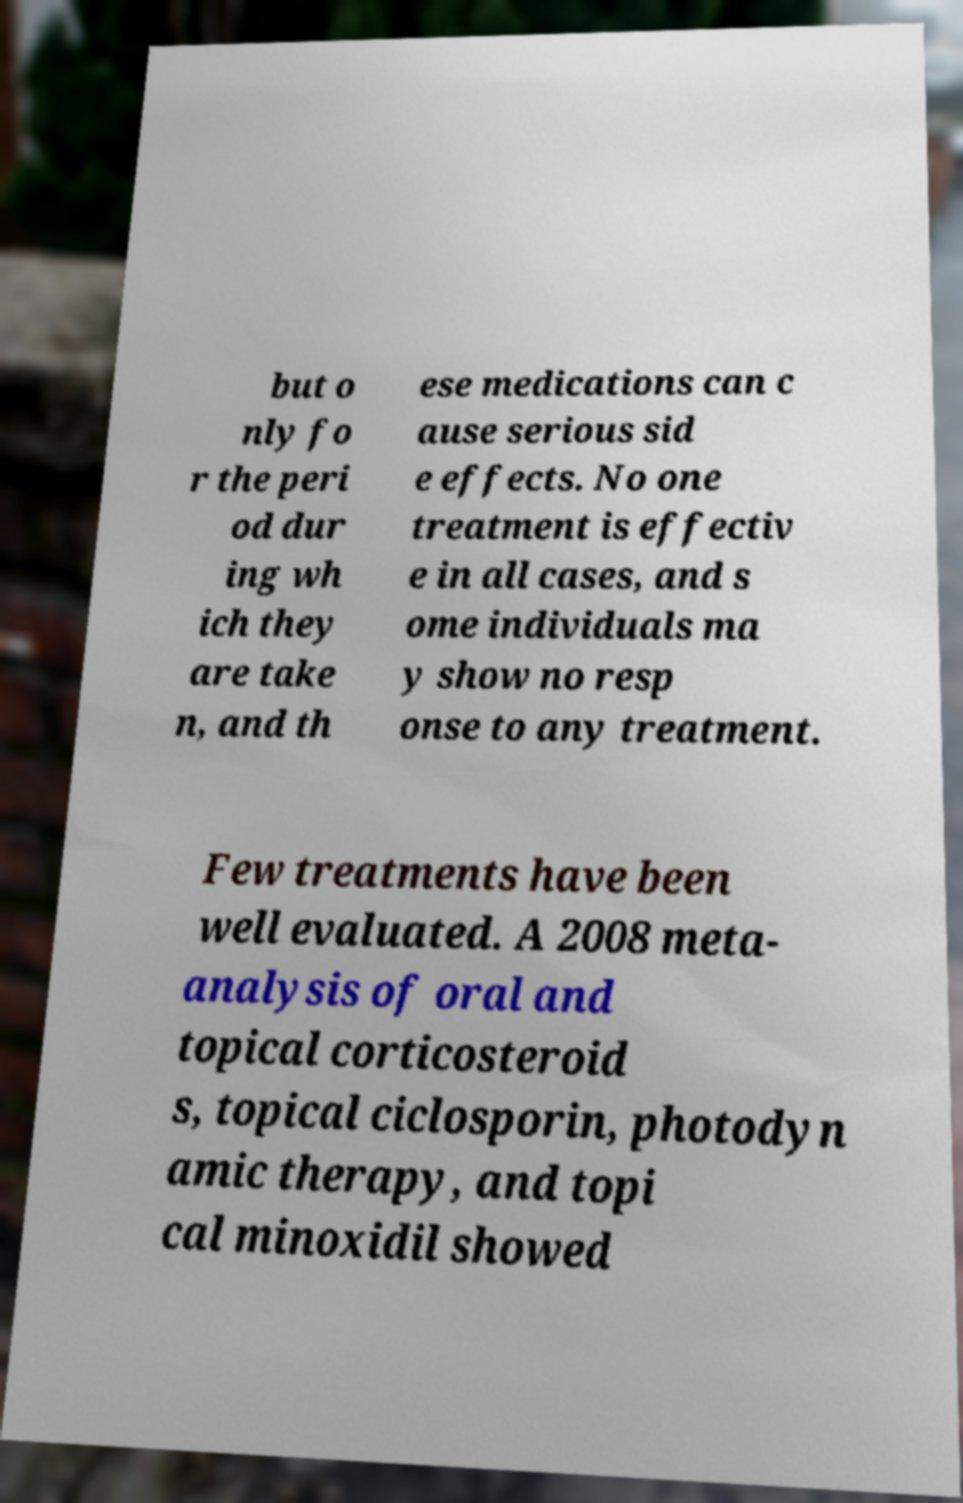Could you assist in decoding the text presented in this image and type it out clearly? but o nly fo r the peri od dur ing wh ich they are take n, and th ese medications can c ause serious sid e effects. No one treatment is effectiv e in all cases, and s ome individuals ma y show no resp onse to any treatment. Few treatments have been well evaluated. A 2008 meta- analysis of oral and topical corticosteroid s, topical ciclosporin, photodyn amic therapy, and topi cal minoxidil showed 